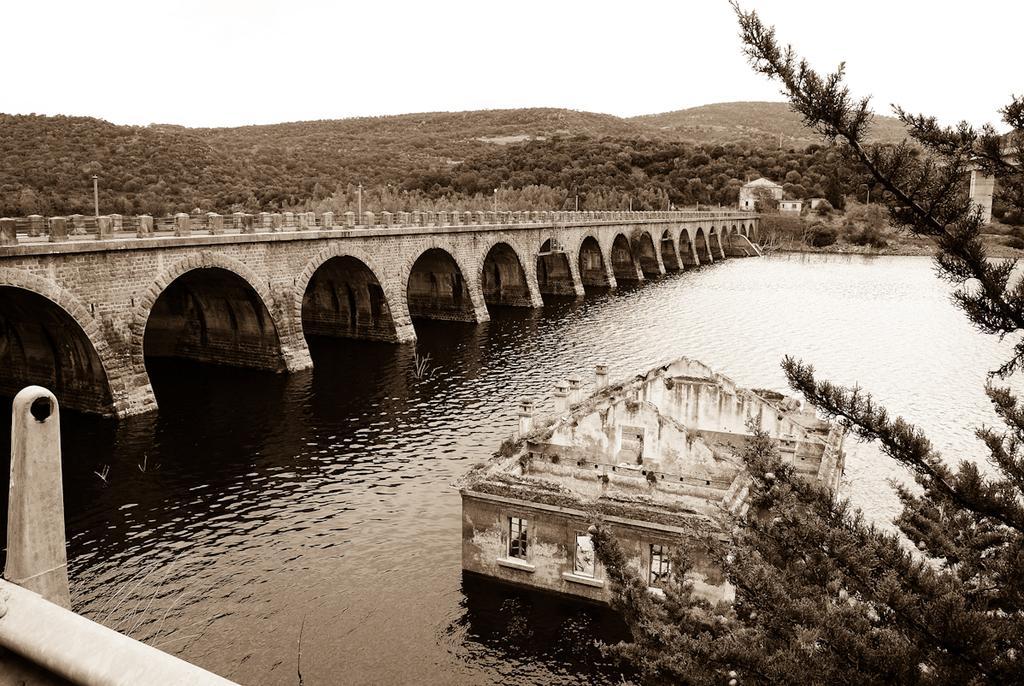How would you summarize this image in a sentence or two? Here in this picture we can see a river present over there, as we can see water present all over there and in the middle of it we can see a building structure present and on the left side we can see a bridge present over there and on the right side and in the middle we can see trees and plants present all over there and in the far we can see mountains fully covered with grass and plants present all over there. 